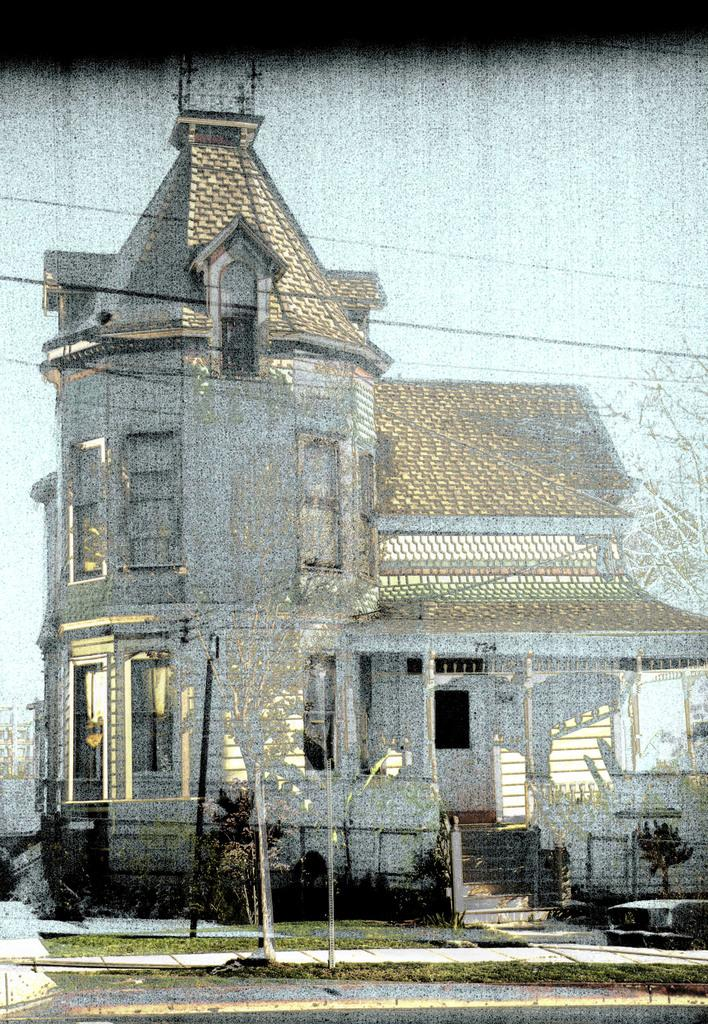What is the main structure visible in the image? There is a building in the image. What type of vegetation is present in front of the building? There are trees in front of the building in the image. How many rings can be seen on the hair of the person standing in front of the building? There is no person with hair or rings visible in the image; it only features a building and trees. 